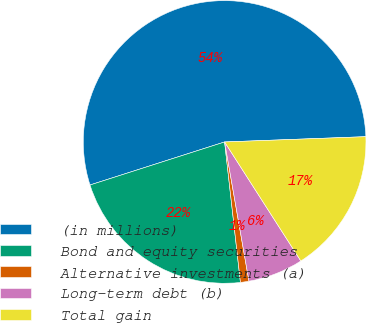Convert chart to OTSL. <chart><loc_0><loc_0><loc_500><loc_500><pie_chart><fcel>(in millions)<fcel>Bond and equity securities<fcel>Alternative investments (a)<fcel>Long-term debt (b)<fcel>Total gain<nl><fcel>54.33%<fcel>21.86%<fcel>0.97%<fcel>6.31%<fcel>16.53%<nl></chart> 